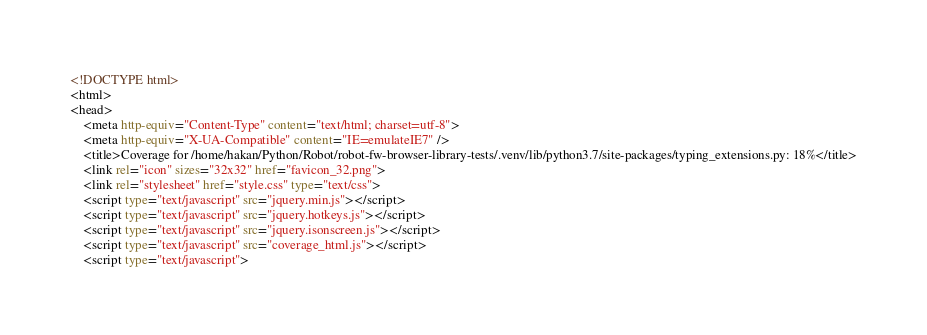<code> <loc_0><loc_0><loc_500><loc_500><_HTML_><!DOCTYPE html>
<html>
<head>
    <meta http-equiv="Content-Type" content="text/html; charset=utf-8">
    <meta http-equiv="X-UA-Compatible" content="IE=emulateIE7" />
    <title>Coverage for /home/hakan/Python/Robot/robot-fw-browser-library-tests/.venv/lib/python3.7/site-packages/typing_extensions.py: 18%</title>
    <link rel="icon" sizes="32x32" href="favicon_32.png">
    <link rel="stylesheet" href="style.css" type="text/css">
    <script type="text/javascript" src="jquery.min.js"></script>
    <script type="text/javascript" src="jquery.hotkeys.js"></script>
    <script type="text/javascript" src="jquery.isonscreen.js"></script>
    <script type="text/javascript" src="coverage_html.js"></script>
    <script type="text/javascript"></code> 